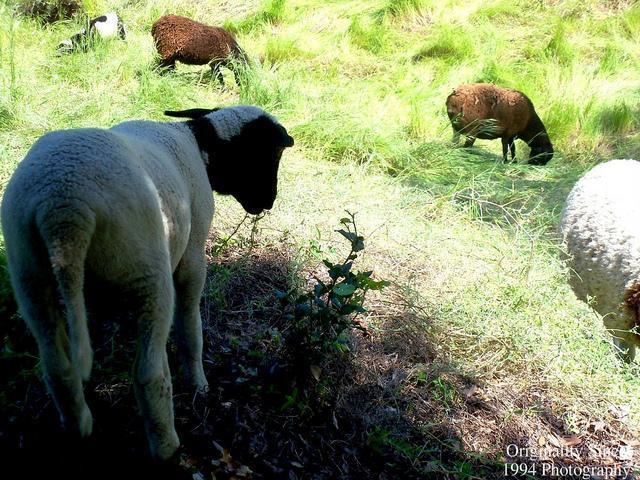How many animals are in the picture?
Give a very brief answer. 5. How many lambs are there?
Give a very brief answer. 4. How many sheep are visible?
Give a very brief answer. 4. 